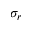<formula> <loc_0><loc_0><loc_500><loc_500>\sigma _ { r }</formula> 